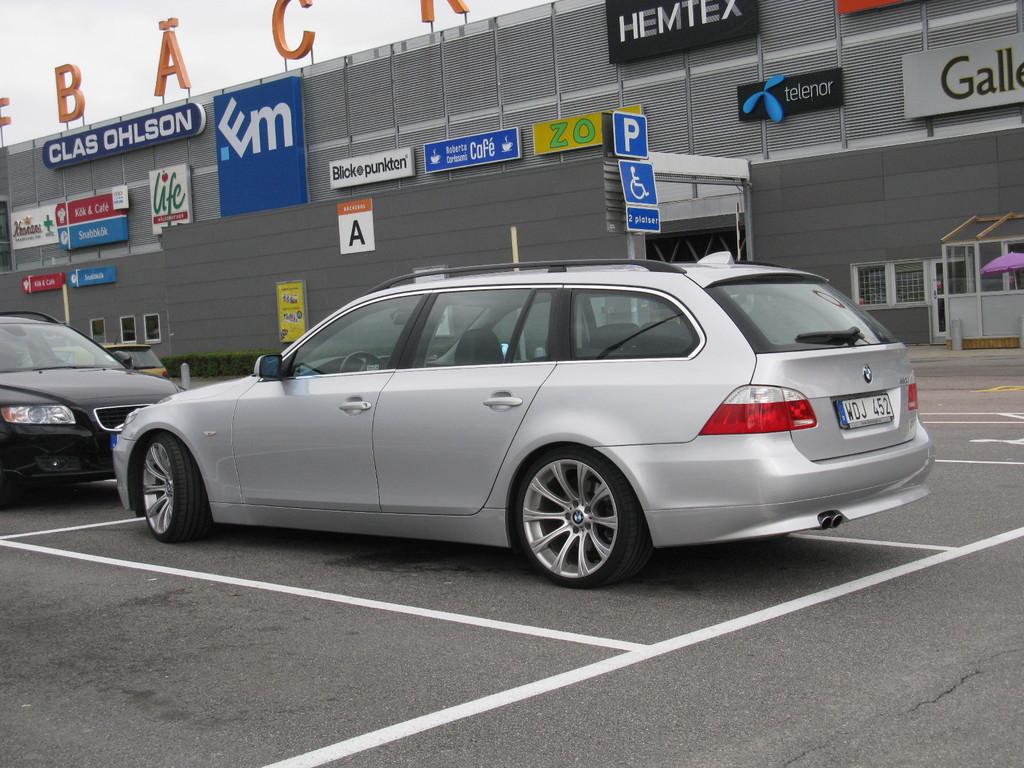What is the licence plate of the silver car?
Give a very brief answer. Wdj 452. The black sign in the middle reads?
Make the answer very short. Hemtex. 